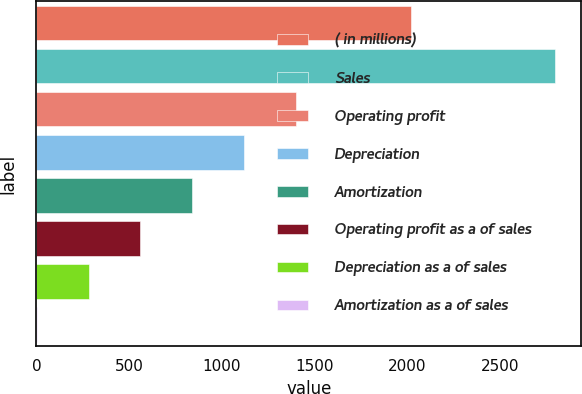Convert chart. <chart><loc_0><loc_0><loc_500><loc_500><bar_chart><fcel>( in millions)<fcel>Sales<fcel>Operating profit<fcel>Depreciation<fcel>Amortization<fcel>Operating profit as a of sales<fcel>Depreciation as a of sales<fcel>Amortization as a of sales<nl><fcel>2018<fcel>2797.6<fcel>1399.35<fcel>1119.7<fcel>840.05<fcel>560.4<fcel>280.75<fcel>1.1<nl></chart> 